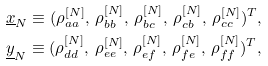Convert formula to latex. <formula><loc_0><loc_0><loc_500><loc_500>& { \underline { x } } _ { N } \equiv ( \rho _ { a a } ^ { [ N ] } , \, \rho _ { b b } ^ { [ N ] } , \, \rho _ { b c } ^ { [ N ] } , \, \rho _ { c b } ^ { [ N ] } , \, \rho _ { c c } ^ { [ N ] } ) ^ { T } , \\ & { \underline { y } } _ { N } \equiv ( \rho _ { d d } ^ { [ N ] } , \, \rho _ { e e } ^ { [ N ] } , \, \rho _ { e f } ^ { [ N ] } , \, \rho _ { f e } ^ { [ N ] } , \, \rho _ { f f } ^ { [ N ] } ) ^ { T } ,</formula> 